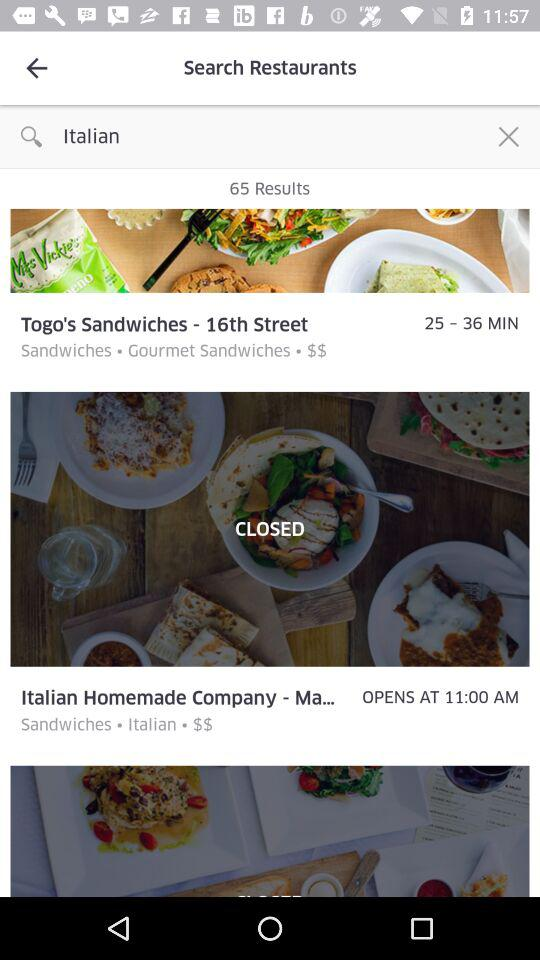What is the delivery time for "Togo's Sandwiches - 16th Street"? The delivery time for "Togo's Sandwiches - 16th Street" is 25 to 36 minutes. 